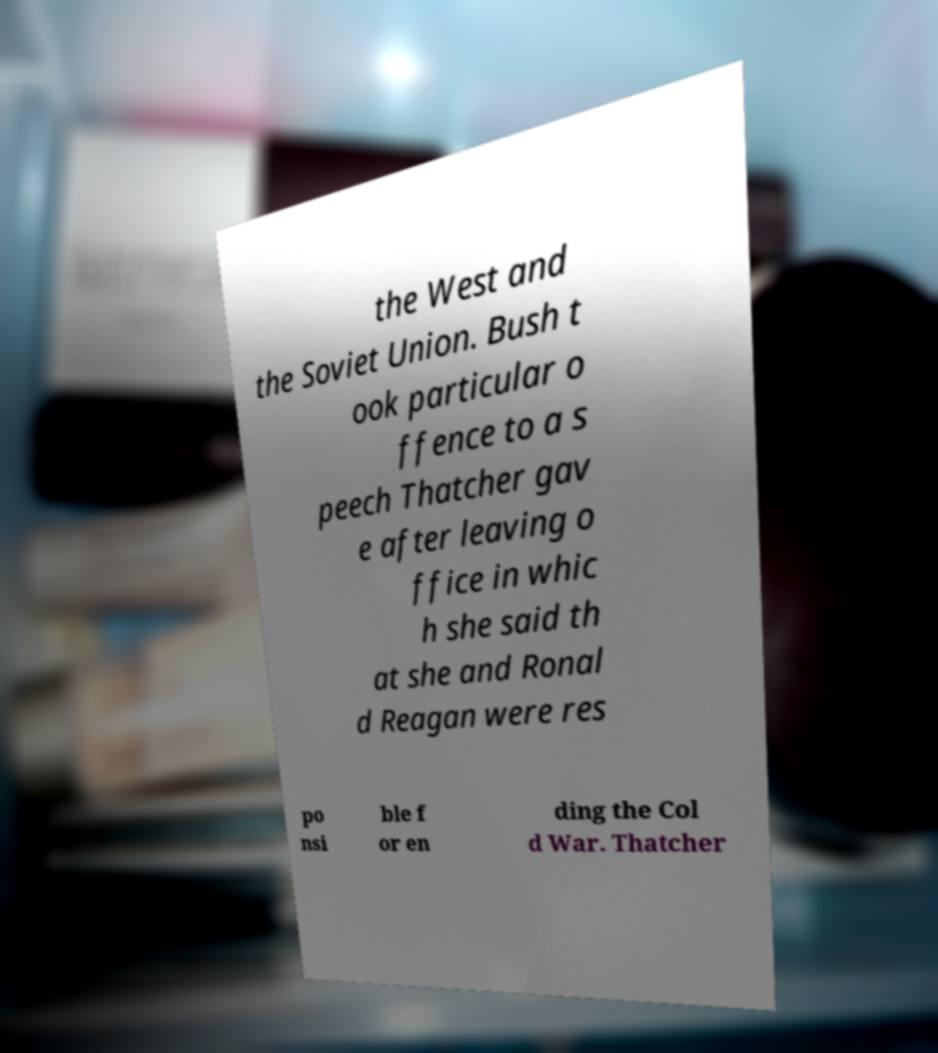Please read and relay the text visible in this image. What does it say? the West and the Soviet Union. Bush t ook particular o ffence to a s peech Thatcher gav e after leaving o ffice in whic h she said th at she and Ronal d Reagan were res po nsi ble f or en ding the Col d War. Thatcher 